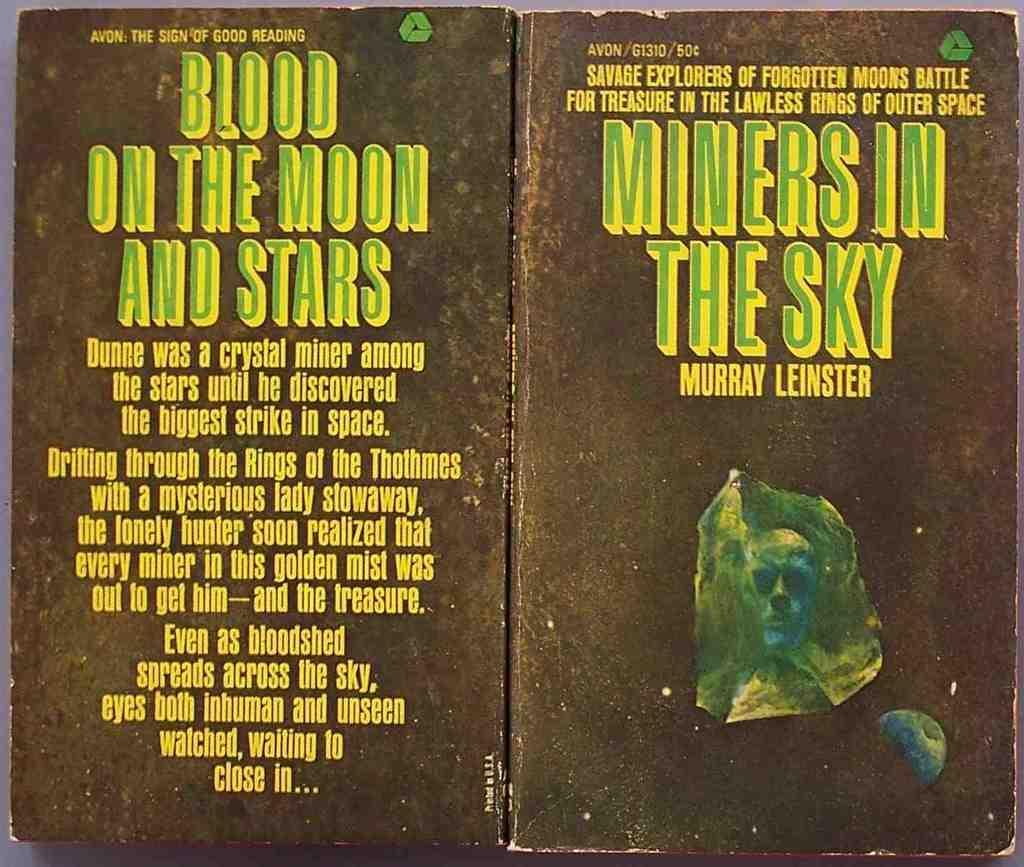<image>
Share a concise interpretation of the image provided. Cover of a book that says the words "Miners in the Sky" on it. 